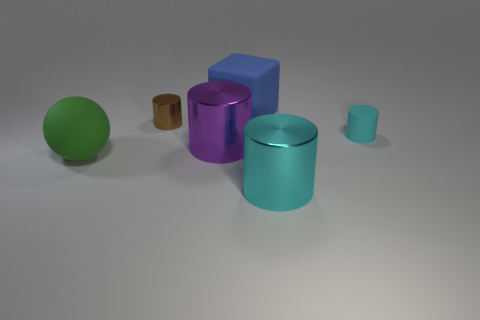Subtract all red cylinders. Subtract all purple spheres. How many cylinders are left? 4 Add 3 blue metal things. How many objects exist? 9 Subtract all balls. How many objects are left? 5 Add 1 large green rubber spheres. How many large green rubber spheres exist? 2 Subtract 1 green balls. How many objects are left? 5 Subtract all big blue cylinders. Subtract all cyan rubber objects. How many objects are left? 5 Add 5 small objects. How many small objects are left? 7 